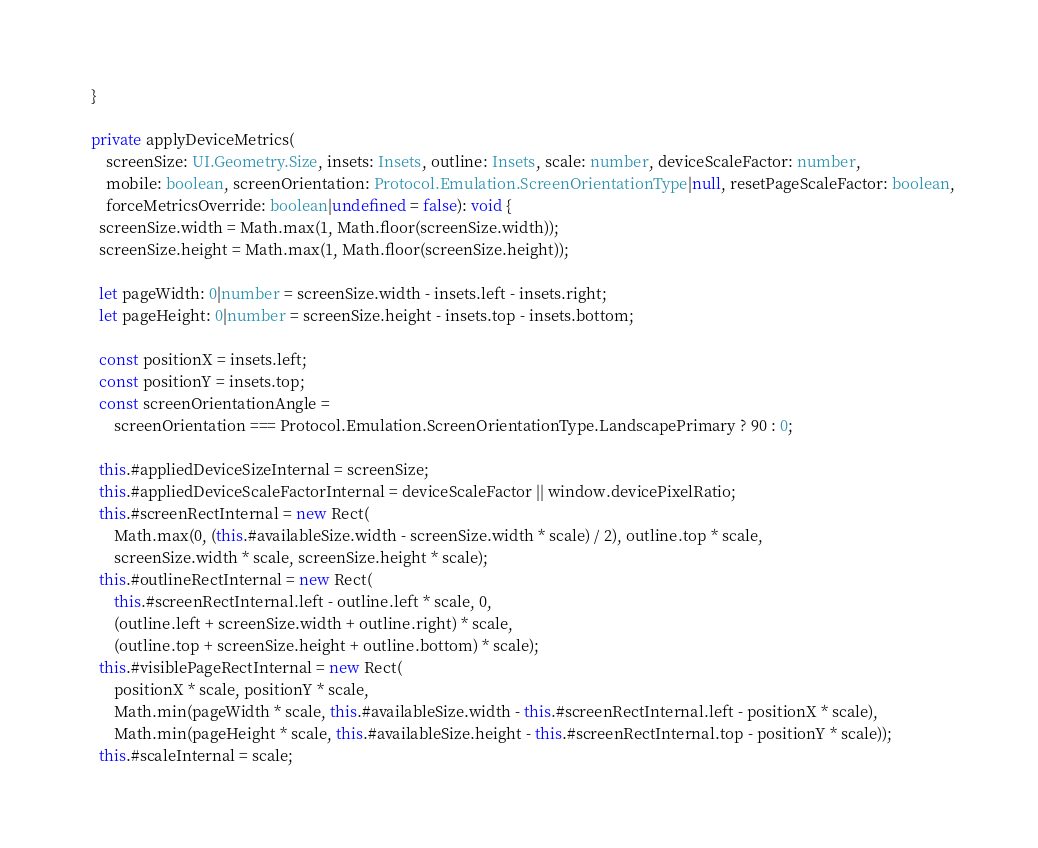Convert code to text. <code><loc_0><loc_0><loc_500><loc_500><_TypeScript_>  }

  private applyDeviceMetrics(
      screenSize: UI.Geometry.Size, insets: Insets, outline: Insets, scale: number, deviceScaleFactor: number,
      mobile: boolean, screenOrientation: Protocol.Emulation.ScreenOrientationType|null, resetPageScaleFactor: boolean,
      forceMetricsOverride: boolean|undefined = false): void {
    screenSize.width = Math.max(1, Math.floor(screenSize.width));
    screenSize.height = Math.max(1, Math.floor(screenSize.height));

    let pageWidth: 0|number = screenSize.width - insets.left - insets.right;
    let pageHeight: 0|number = screenSize.height - insets.top - insets.bottom;

    const positionX = insets.left;
    const positionY = insets.top;
    const screenOrientationAngle =
        screenOrientation === Protocol.Emulation.ScreenOrientationType.LandscapePrimary ? 90 : 0;

    this.#appliedDeviceSizeInternal = screenSize;
    this.#appliedDeviceScaleFactorInternal = deviceScaleFactor || window.devicePixelRatio;
    this.#screenRectInternal = new Rect(
        Math.max(0, (this.#availableSize.width - screenSize.width * scale) / 2), outline.top * scale,
        screenSize.width * scale, screenSize.height * scale);
    this.#outlineRectInternal = new Rect(
        this.#screenRectInternal.left - outline.left * scale, 0,
        (outline.left + screenSize.width + outline.right) * scale,
        (outline.top + screenSize.height + outline.bottom) * scale);
    this.#visiblePageRectInternal = new Rect(
        positionX * scale, positionY * scale,
        Math.min(pageWidth * scale, this.#availableSize.width - this.#screenRectInternal.left - positionX * scale),
        Math.min(pageHeight * scale, this.#availableSize.height - this.#screenRectInternal.top - positionY * scale));
    this.#scaleInternal = scale;</code> 